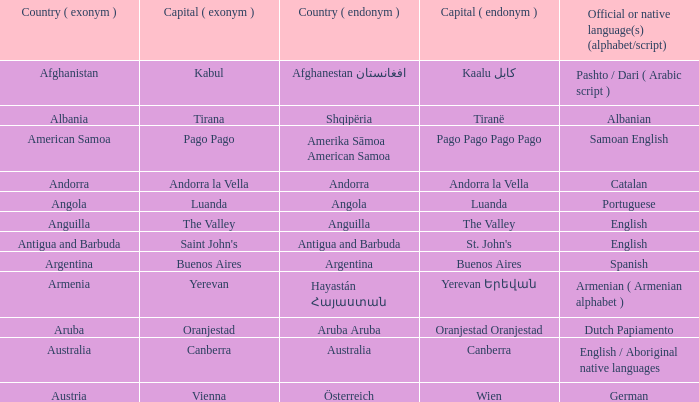What is the English name of the country whose official native language is Dutch Papiamento? Aruba. 